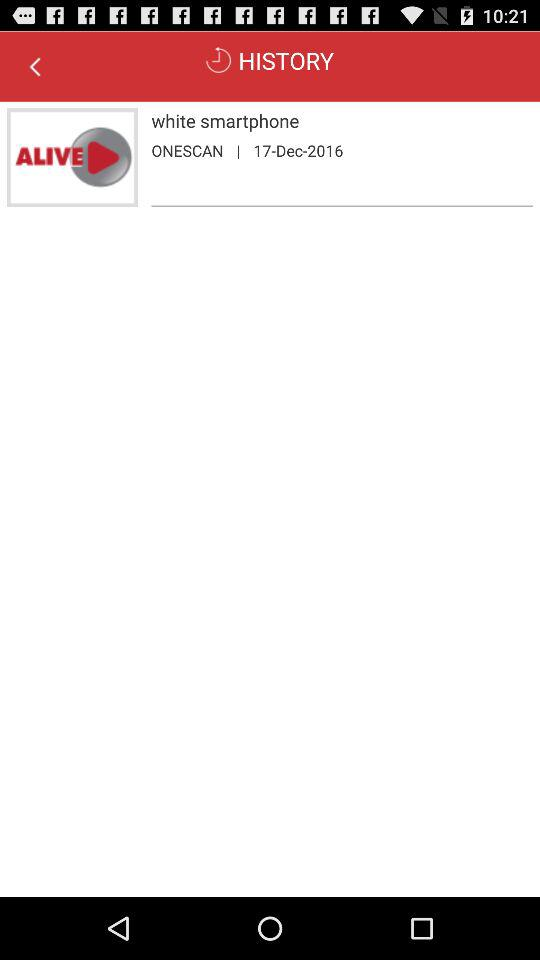What is given in history? It's the "white smartphone" in history. 